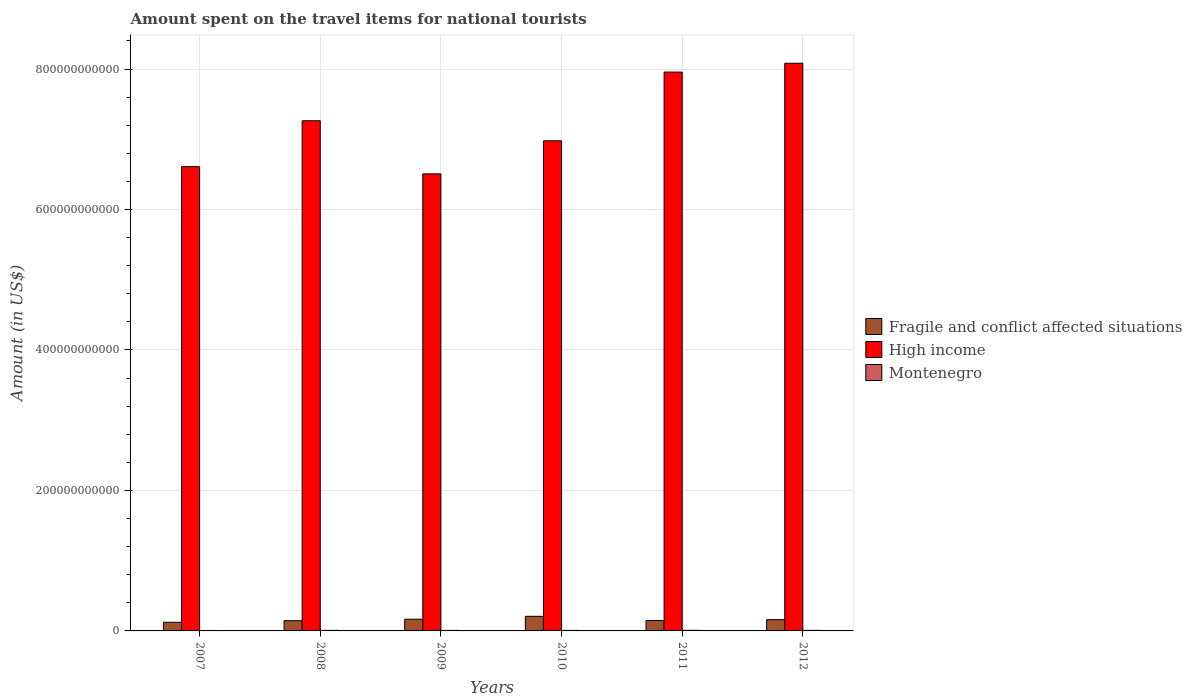How many different coloured bars are there?
Give a very brief answer. 3. Are the number of bars per tick equal to the number of legend labels?
Your response must be concise. Yes. How many bars are there on the 5th tick from the left?
Your answer should be very brief. 3. What is the label of the 6th group of bars from the left?
Provide a succinct answer. 2012. In how many cases, is the number of bars for a given year not equal to the number of legend labels?
Make the answer very short. 0. What is the amount spent on the travel items for national tourists in High income in 2009?
Your answer should be compact. 6.51e+11. Across all years, what is the maximum amount spent on the travel items for national tourists in Fragile and conflict affected situations?
Keep it short and to the point. 2.08e+1. Across all years, what is the minimum amount spent on the travel items for national tourists in High income?
Offer a terse response. 6.51e+11. What is the total amount spent on the travel items for national tourists in High income in the graph?
Make the answer very short. 4.34e+12. What is the difference between the amount spent on the travel items for national tourists in High income in 2009 and that in 2011?
Make the answer very short. -1.45e+11. What is the difference between the amount spent on the travel items for national tourists in High income in 2009 and the amount spent on the travel items for national tourists in Fragile and conflict affected situations in 2012?
Provide a succinct answer. 6.35e+11. What is the average amount spent on the travel items for national tourists in High income per year?
Give a very brief answer. 7.23e+11. In the year 2011, what is the difference between the amount spent on the travel items for national tourists in Montenegro and amount spent on the travel items for national tourists in High income?
Offer a terse response. -7.95e+11. What is the ratio of the amount spent on the travel items for national tourists in Fragile and conflict affected situations in 2008 to that in 2011?
Make the answer very short. 0.98. What is the difference between the highest and the second highest amount spent on the travel items for national tourists in Montenegro?
Provide a short and direct response. 6.20e+07. What is the difference between the highest and the lowest amount spent on the travel items for national tourists in Fragile and conflict affected situations?
Provide a short and direct response. 8.52e+09. Is the sum of the amount spent on the travel items for national tourists in High income in 2008 and 2011 greater than the maximum amount spent on the travel items for national tourists in Montenegro across all years?
Provide a short and direct response. Yes. What does the 3rd bar from the right in 2012 represents?
Provide a succinct answer. Fragile and conflict affected situations. Is it the case that in every year, the sum of the amount spent on the travel items for national tourists in High income and amount spent on the travel items for national tourists in Montenegro is greater than the amount spent on the travel items for national tourists in Fragile and conflict affected situations?
Your answer should be compact. Yes. What is the difference between two consecutive major ticks on the Y-axis?
Your answer should be compact. 2.00e+11. Does the graph contain any zero values?
Give a very brief answer. No. How many legend labels are there?
Keep it short and to the point. 3. What is the title of the graph?
Keep it short and to the point. Amount spent on the travel items for national tourists. What is the label or title of the X-axis?
Make the answer very short. Years. What is the Amount (in US$) in Fragile and conflict affected situations in 2007?
Your response must be concise. 1.23e+1. What is the Amount (in US$) of High income in 2007?
Keep it short and to the point. 6.61e+11. What is the Amount (in US$) of Montenegro in 2007?
Your answer should be very brief. 6.30e+08. What is the Amount (in US$) in Fragile and conflict affected situations in 2008?
Ensure brevity in your answer.  1.46e+1. What is the Amount (in US$) of High income in 2008?
Make the answer very short. 7.26e+11. What is the Amount (in US$) in Montenegro in 2008?
Make the answer very short. 8.13e+08. What is the Amount (in US$) in Fragile and conflict affected situations in 2009?
Offer a very short reply. 1.67e+1. What is the Amount (in US$) of High income in 2009?
Your answer should be very brief. 6.51e+11. What is the Amount (in US$) in Montenegro in 2009?
Your answer should be very brief. 7.45e+08. What is the Amount (in US$) in Fragile and conflict affected situations in 2010?
Provide a short and direct response. 2.08e+1. What is the Amount (in US$) of High income in 2010?
Keep it short and to the point. 6.98e+11. What is the Amount (in US$) of Montenegro in 2010?
Make the answer very short. 7.13e+08. What is the Amount (in US$) of Fragile and conflict affected situations in 2011?
Keep it short and to the point. 1.48e+1. What is the Amount (in US$) of High income in 2011?
Provide a short and direct response. 7.96e+11. What is the Amount (in US$) in Montenegro in 2011?
Offer a terse response. 8.75e+08. What is the Amount (in US$) of Fragile and conflict affected situations in 2012?
Ensure brevity in your answer.  1.60e+1. What is the Amount (in US$) of High income in 2012?
Your answer should be very brief. 8.08e+11. What is the Amount (in US$) in Montenegro in 2012?
Offer a very short reply. 8.09e+08. Across all years, what is the maximum Amount (in US$) in Fragile and conflict affected situations?
Provide a short and direct response. 2.08e+1. Across all years, what is the maximum Amount (in US$) of High income?
Provide a short and direct response. 8.08e+11. Across all years, what is the maximum Amount (in US$) of Montenegro?
Offer a terse response. 8.75e+08. Across all years, what is the minimum Amount (in US$) in Fragile and conflict affected situations?
Offer a very short reply. 1.23e+1. Across all years, what is the minimum Amount (in US$) in High income?
Provide a succinct answer. 6.51e+11. Across all years, what is the minimum Amount (in US$) of Montenegro?
Give a very brief answer. 6.30e+08. What is the total Amount (in US$) in Fragile and conflict affected situations in the graph?
Offer a terse response. 9.52e+1. What is the total Amount (in US$) in High income in the graph?
Keep it short and to the point. 4.34e+12. What is the total Amount (in US$) in Montenegro in the graph?
Your response must be concise. 4.58e+09. What is the difference between the Amount (in US$) of Fragile and conflict affected situations in 2007 and that in 2008?
Ensure brevity in your answer.  -2.30e+09. What is the difference between the Amount (in US$) in High income in 2007 and that in 2008?
Give a very brief answer. -6.53e+1. What is the difference between the Amount (in US$) of Montenegro in 2007 and that in 2008?
Your answer should be compact. -1.83e+08. What is the difference between the Amount (in US$) of Fragile and conflict affected situations in 2007 and that in 2009?
Make the answer very short. -4.39e+09. What is the difference between the Amount (in US$) of High income in 2007 and that in 2009?
Keep it short and to the point. 1.03e+1. What is the difference between the Amount (in US$) in Montenegro in 2007 and that in 2009?
Ensure brevity in your answer.  -1.15e+08. What is the difference between the Amount (in US$) in Fragile and conflict affected situations in 2007 and that in 2010?
Your answer should be very brief. -8.52e+09. What is the difference between the Amount (in US$) in High income in 2007 and that in 2010?
Your answer should be compact. -3.68e+1. What is the difference between the Amount (in US$) in Montenegro in 2007 and that in 2010?
Keep it short and to the point. -8.30e+07. What is the difference between the Amount (in US$) of Fragile and conflict affected situations in 2007 and that in 2011?
Ensure brevity in your answer.  -2.55e+09. What is the difference between the Amount (in US$) in High income in 2007 and that in 2011?
Offer a very short reply. -1.35e+11. What is the difference between the Amount (in US$) in Montenegro in 2007 and that in 2011?
Offer a very short reply. -2.45e+08. What is the difference between the Amount (in US$) of Fragile and conflict affected situations in 2007 and that in 2012?
Offer a very short reply. -3.75e+09. What is the difference between the Amount (in US$) of High income in 2007 and that in 2012?
Provide a succinct answer. -1.47e+11. What is the difference between the Amount (in US$) in Montenegro in 2007 and that in 2012?
Your response must be concise. -1.79e+08. What is the difference between the Amount (in US$) in Fragile and conflict affected situations in 2008 and that in 2009?
Provide a short and direct response. -2.10e+09. What is the difference between the Amount (in US$) in High income in 2008 and that in 2009?
Make the answer very short. 7.56e+1. What is the difference between the Amount (in US$) of Montenegro in 2008 and that in 2009?
Keep it short and to the point. 6.80e+07. What is the difference between the Amount (in US$) in Fragile and conflict affected situations in 2008 and that in 2010?
Give a very brief answer. -6.22e+09. What is the difference between the Amount (in US$) of High income in 2008 and that in 2010?
Your answer should be compact. 2.85e+1. What is the difference between the Amount (in US$) in Fragile and conflict affected situations in 2008 and that in 2011?
Make the answer very short. -2.51e+08. What is the difference between the Amount (in US$) in High income in 2008 and that in 2011?
Make the answer very short. -6.93e+1. What is the difference between the Amount (in US$) of Montenegro in 2008 and that in 2011?
Your answer should be very brief. -6.20e+07. What is the difference between the Amount (in US$) in Fragile and conflict affected situations in 2008 and that in 2012?
Give a very brief answer. -1.45e+09. What is the difference between the Amount (in US$) of High income in 2008 and that in 2012?
Keep it short and to the point. -8.19e+1. What is the difference between the Amount (in US$) of Fragile and conflict affected situations in 2009 and that in 2010?
Your answer should be very brief. -4.12e+09. What is the difference between the Amount (in US$) in High income in 2009 and that in 2010?
Offer a terse response. -4.71e+1. What is the difference between the Amount (in US$) of Montenegro in 2009 and that in 2010?
Provide a short and direct response. 3.20e+07. What is the difference between the Amount (in US$) of Fragile and conflict affected situations in 2009 and that in 2011?
Give a very brief answer. 1.85e+09. What is the difference between the Amount (in US$) of High income in 2009 and that in 2011?
Provide a succinct answer. -1.45e+11. What is the difference between the Amount (in US$) of Montenegro in 2009 and that in 2011?
Give a very brief answer. -1.30e+08. What is the difference between the Amount (in US$) of Fragile and conflict affected situations in 2009 and that in 2012?
Keep it short and to the point. 6.47e+08. What is the difference between the Amount (in US$) in High income in 2009 and that in 2012?
Your response must be concise. -1.58e+11. What is the difference between the Amount (in US$) of Montenegro in 2009 and that in 2012?
Your response must be concise. -6.40e+07. What is the difference between the Amount (in US$) of Fragile and conflict affected situations in 2010 and that in 2011?
Provide a succinct answer. 5.97e+09. What is the difference between the Amount (in US$) of High income in 2010 and that in 2011?
Provide a succinct answer. -9.78e+1. What is the difference between the Amount (in US$) in Montenegro in 2010 and that in 2011?
Make the answer very short. -1.62e+08. What is the difference between the Amount (in US$) in Fragile and conflict affected situations in 2010 and that in 2012?
Your answer should be very brief. 4.77e+09. What is the difference between the Amount (in US$) of High income in 2010 and that in 2012?
Your response must be concise. -1.10e+11. What is the difference between the Amount (in US$) of Montenegro in 2010 and that in 2012?
Provide a short and direct response. -9.60e+07. What is the difference between the Amount (in US$) of Fragile and conflict affected situations in 2011 and that in 2012?
Give a very brief answer. -1.20e+09. What is the difference between the Amount (in US$) in High income in 2011 and that in 2012?
Your answer should be very brief. -1.25e+1. What is the difference between the Amount (in US$) of Montenegro in 2011 and that in 2012?
Make the answer very short. 6.60e+07. What is the difference between the Amount (in US$) of Fragile and conflict affected situations in 2007 and the Amount (in US$) of High income in 2008?
Ensure brevity in your answer.  -7.14e+11. What is the difference between the Amount (in US$) in Fragile and conflict affected situations in 2007 and the Amount (in US$) in Montenegro in 2008?
Offer a very short reply. 1.15e+1. What is the difference between the Amount (in US$) of High income in 2007 and the Amount (in US$) of Montenegro in 2008?
Your response must be concise. 6.60e+11. What is the difference between the Amount (in US$) in Fragile and conflict affected situations in 2007 and the Amount (in US$) in High income in 2009?
Your response must be concise. -6.38e+11. What is the difference between the Amount (in US$) in Fragile and conflict affected situations in 2007 and the Amount (in US$) in Montenegro in 2009?
Your answer should be compact. 1.15e+1. What is the difference between the Amount (in US$) of High income in 2007 and the Amount (in US$) of Montenegro in 2009?
Give a very brief answer. 6.60e+11. What is the difference between the Amount (in US$) of Fragile and conflict affected situations in 2007 and the Amount (in US$) of High income in 2010?
Offer a very short reply. -6.86e+11. What is the difference between the Amount (in US$) in Fragile and conflict affected situations in 2007 and the Amount (in US$) in Montenegro in 2010?
Your answer should be compact. 1.16e+1. What is the difference between the Amount (in US$) of High income in 2007 and the Amount (in US$) of Montenegro in 2010?
Offer a terse response. 6.60e+11. What is the difference between the Amount (in US$) of Fragile and conflict affected situations in 2007 and the Amount (in US$) of High income in 2011?
Provide a succinct answer. -7.83e+11. What is the difference between the Amount (in US$) in Fragile and conflict affected situations in 2007 and the Amount (in US$) in Montenegro in 2011?
Your response must be concise. 1.14e+1. What is the difference between the Amount (in US$) of High income in 2007 and the Amount (in US$) of Montenegro in 2011?
Offer a very short reply. 6.60e+11. What is the difference between the Amount (in US$) of Fragile and conflict affected situations in 2007 and the Amount (in US$) of High income in 2012?
Provide a succinct answer. -7.96e+11. What is the difference between the Amount (in US$) of Fragile and conflict affected situations in 2007 and the Amount (in US$) of Montenegro in 2012?
Make the answer very short. 1.15e+1. What is the difference between the Amount (in US$) of High income in 2007 and the Amount (in US$) of Montenegro in 2012?
Your answer should be compact. 6.60e+11. What is the difference between the Amount (in US$) in Fragile and conflict affected situations in 2008 and the Amount (in US$) in High income in 2009?
Your answer should be very brief. -6.36e+11. What is the difference between the Amount (in US$) in Fragile and conflict affected situations in 2008 and the Amount (in US$) in Montenegro in 2009?
Keep it short and to the point. 1.38e+1. What is the difference between the Amount (in US$) in High income in 2008 and the Amount (in US$) in Montenegro in 2009?
Your answer should be compact. 7.26e+11. What is the difference between the Amount (in US$) in Fragile and conflict affected situations in 2008 and the Amount (in US$) in High income in 2010?
Ensure brevity in your answer.  -6.83e+11. What is the difference between the Amount (in US$) in Fragile and conflict affected situations in 2008 and the Amount (in US$) in Montenegro in 2010?
Offer a terse response. 1.39e+1. What is the difference between the Amount (in US$) of High income in 2008 and the Amount (in US$) of Montenegro in 2010?
Provide a succinct answer. 7.26e+11. What is the difference between the Amount (in US$) in Fragile and conflict affected situations in 2008 and the Amount (in US$) in High income in 2011?
Make the answer very short. -7.81e+11. What is the difference between the Amount (in US$) in Fragile and conflict affected situations in 2008 and the Amount (in US$) in Montenegro in 2011?
Provide a short and direct response. 1.37e+1. What is the difference between the Amount (in US$) in High income in 2008 and the Amount (in US$) in Montenegro in 2011?
Your answer should be very brief. 7.26e+11. What is the difference between the Amount (in US$) of Fragile and conflict affected situations in 2008 and the Amount (in US$) of High income in 2012?
Ensure brevity in your answer.  -7.94e+11. What is the difference between the Amount (in US$) in Fragile and conflict affected situations in 2008 and the Amount (in US$) in Montenegro in 2012?
Your answer should be compact. 1.38e+1. What is the difference between the Amount (in US$) in High income in 2008 and the Amount (in US$) in Montenegro in 2012?
Offer a very short reply. 7.26e+11. What is the difference between the Amount (in US$) in Fragile and conflict affected situations in 2009 and the Amount (in US$) in High income in 2010?
Keep it short and to the point. -6.81e+11. What is the difference between the Amount (in US$) of Fragile and conflict affected situations in 2009 and the Amount (in US$) of Montenegro in 2010?
Your answer should be compact. 1.60e+1. What is the difference between the Amount (in US$) of High income in 2009 and the Amount (in US$) of Montenegro in 2010?
Give a very brief answer. 6.50e+11. What is the difference between the Amount (in US$) of Fragile and conflict affected situations in 2009 and the Amount (in US$) of High income in 2011?
Offer a terse response. -7.79e+11. What is the difference between the Amount (in US$) of Fragile and conflict affected situations in 2009 and the Amount (in US$) of Montenegro in 2011?
Offer a very short reply. 1.58e+1. What is the difference between the Amount (in US$) of High income in 2009 and the Amount (in US$) of Montenegro in 2011?
Keep it short and to the point. 6.50e+11. What is the difference between the Amount (in US$) in Fragile and conflict affected situations in 2009 and the Amount (in US$) in High income in 2012?
Give a very brief answer. -7.92e+11. What is the difference between the Amount (in US$) of Fragile and conflict affected situations in 2009 and the Amount (in US$) of Montenegro in 2012?
Your answer should be compact. 1.59e+1. What is the difference between the Amount (in US$) in High income in 2009 and the Amount (in US$) in Montenegro in 2012?
Offer a terse response. 6.50e+11. What is the difference between the Amount (in US$) in Fragile and conflict affected situations in 2010 and the Amount (in US$) in High income in 2011?
Ensure brevity in your answer.  -7.75e+11. What is the difference between the Amount (in US$) in Fragile and conflict affected situations in 2010 and the Amount (in US$) in Montenegro in 2011?
Give a very brief answer. 1.99e+1. What is the difference between the Amount (in US$) in High income in 2010 and the Amount (in US$) in Montenegro in 2011?
Offer a terse response. 6.97e+11. What is the difference between the Amount (in US$) in Fragile and conflict affected situations in 2010 and the Amount (in US$) in High income in 2012?
Give a very brief answer. -7.87e+11. What is the difference between the Amount (in US$) in Fragile and conflict affected situations in 2010 and the Amount (in US$) in Montenegro in 2012?
Ensure brevity in your answer.  2.00e+1. What is the difference between the Amount (in US$) of High income in 2010 and the Amount (in US$) of Montenegro in 2012?
Ensure brevity in your answer.  6.97e+11. What is the difference between the Amount (in US$) of Fragile and conflict affected situations in 2011 and the Amount (in US$) of High income in 2012?
Offer a very short reply. -7.93e+11. What is the difference between the Amount (in US$) in Fragile and conflict affected situations in 2011 and the Amount (in US$) in Montenegro in 2012?
Keep it short and to the point. 1.40e+1. What is the difference between the Amount (in US$) of High income in 2011 and the Amount (in US$) of Montenegro in 2012?
Give a very brief answer. 7.95e+11. What is the average Amount (in US$) of Fragile and conflict affected situations per year?
Your answer should be compact. 1.59e+1. What is the average Amount (in US$) of High income per year?
Make the answer very short. 7.23e+11. What is the average Amount (in US$) of Montenegro per year?
Provide a succinct answer. 7.64e+08. In the year 2007, what is the difference between the Amount (in US$) in Fragile and conflict affected situations and Amount (in US$) in High income?
Ensure brevity in your answer.  -6.49e+11. In the year 2007, what is the difference between the Amount (in US$) of Fragile and conflict affected situations and Amount (in US$) of Montenegro?
Ensure brevity in your answer.  1.16e+1. In the year 2007, what is the difference between the Amount (in US$) in High income and Amount (in US$) in Montenegro?
Offer a terse response. 6.60e+11. In the year 2008, what is the difference between the Amount (in US$) in Fragile and conflict affected situations and Amount (in US$) in High income?
Give a very brief answer. -7.12e+11. In the year 2008, what is the difference between the Amount (in US$) in Fragile and conflict affected situations and Amount (in US$) in Montenegro?
Offer a terse response. 1.38e+1. In the year 2008, what is the difference between the Amount (in US$) in High income and Amount (in US$) in Montenegro?
Ensure brevity in your answer.  7.26e+11. In the year 2009, what is the difference between the Amount (in US$) of Fragile and conflict affected situations and Amount (in US$) of High income?
Your answer should be very brief. -6.34e+11. In the year 2009, what is the difference between the Amount (in US$) of Fragile and conflict affected situations and Amount (in US$) of Montenegro?
Make the answer very short. 1.59e+1. In the year 2009, what is the difference between the Amount (in US$) of High income and Amount (in US$) of Montenegro?
Make the answer very short. 6.50e+11. In the year 2010, what is the difference between the Amount (in US$) of Fragile and conflict affected situations and Amount (in US$) of High income?
Ensure brevity in your answer.  -6.77e+11. In the year 2010, what is the difference between the Amount (in US$) in Fragile and conflict affected situations and Amount (in US$) in Montenegro?
Ensure brevity in your answer.  2.01e+1. In the year 2010, what is the difference between the Amount (in US$) of High income and Amount (in US$) of Montenegro?
Keep it short and to the point. 6.97e+11. In the year 2011, what is the difference between the Amount (in US$) in Fragile and conflict affected situations and Amount (in US$) in High income?
Give a very brief answer. -7.81e+11. In the year 2011, what is the difference between the Amount (in US$) of Fragile and conflict affected situations and Amount (in US$) of Montenegro?
Ensure brevity in your answer.  1.40e+1. In the year 2011, what is the difference between the Amount (in US$) of High income and Amount (in US$) of Montenegro?
Provide a short and direct response. 7.95e+11. In the year 2012, what is the difference between the Amount (in US$) of Fragile and conflict affected situations and Amount (in US$) of High income?
Your answer should be very brief. -7.92e+11. In the year 2012, what is the difference between the Amount (in US$) in Fragile and conflict affected situations and Amount (in US$) in Montenegro?
Provide a succinct answer. 1.52e+1. In the year 2012, what is the difference between the Amount (in US$) in High income and Amount (in US$) in Montenegro?
Keep it short and to the point. 8.07e+11. What is the ratio of the Amount (in US$) in Fragile and conflict affected situations in 2007 to that in 2008?
Ensure brevity in your answer.  0.84. What is the ratio of the Amount (in US$) in High income in 2007 to that in 2008?
Keep it short and to the point. 0.91. What is the ratio of the Amount (in US$) in Montenegro in 2007 to that in 2008?
Make the answer very short. 0.77. What is the ratio of the Amount (in US$) in Fragile and conflict affected situations in 2007 to that in 2009?
Your answer should be very brief. 0.74. What is the ratio of the Amount (in US$) in High income in 2007 to that in 2009?
Keep it short and to the point. 1.02. What is the ratio of the Amount (in US$) of Montenegro in 2007 to that in 2009?
Keep it short and to the point. 0.85. What is the ratio of the Amount (in US$) of Fragile and conflict affected situations in 2007 to that in 2010?
Offer a very short reply. 0.59. What is the ratio of the Amount (in US$) in High income in 2007 to that in 2010?
Give a very brief answer. 0.95. What is the ratio of the Amount (in US$) of Montenegro in 2007 to that in 2010?
Offer a very short reply. 0.88. What is the ratio of the Amount (in US$) in Fragile and conflict affected situations in 2007 to that in 2011?
Ensure brevity in your answer.  0.83. What is the ratio of the Amount (in US$) of High income in 2007 to that in 2011?
Ensure brevity in your answer.  0.83. What is the ratio of the Amount (in US$) of Montenegro in 2007 to that in 2011?
Offer a terse response. 0.72. What is the ratio of the Amount (in US$) in Fragile and conflict affected situations in 2007 to that in 2012?
Give a very brief answer. 0.77. What is the ratio of the Amount (in US$) in High income in 2007 to that in 2012?
Your answer should be compact. 0.82. What is the ratio of the Amount (in US$) of Montenegro in 2007 to that in 2012?
Provide a succinct answer. 0.78. What is the ratio of the Amount (in US$) of Fragile and conflict affected situations in 2008 to that in 2009?
Your answer should be very brief. 0.87. What is the ratio of the Amount (in US$) in High income in 2008 to that in 2009?
Give a very brief answer. 1.12. What is the ratio of the Amount (in US$) of Montenegro in 2008 to that in 2009?
Keep it short and to the point. 1.09. What is the ratio of the Amount (in US$) of Fragile and conflict affected situations in 2008 to that in 2010?
Make the answer very short. 0.7. What is the ratio of the Amount (in US$) in High income in 2008 to that in 2010?
Make the answer very short. 1.04. What is the ratio of the Amount (in US$) of Montenegro in 2008 to that in 2010?
Provide a short and direct response. 1.14. What is the ratio of the Amount (in US$) of Fragile and conflict affected situations in 2008 to that in 2011?
Offer a very short reply. 0.98. What is the ratio of the Amount (in US$) of High income in 2008 to that in 2011?
Provide a short and direct response. 0.91. What is the ratio of the Amount (in US$) in Montenegro in 2008 to that in 2011?
Keep it short and to the point. 0.93. What is the ratio of the Amount (in US$) in Fragile and conflict affected situations in 2008 to that in 2012?
Ensure brevity in your answer.  0.91. What is the ratio of the Amount (in US$) in High income in 2008 to that in 2012?
Offer a very short reply. 0.9. What is the ratio of the Amount (in US$) in Fragile and conflict affected situations in 2009 to that in 2010?
Offer a terse response. 0.8. What is the ratio of the Amount (in US$) in High income in 2009 to that in 2010?
Give a very brief answer. 0.93. What is the ratio of the Amount (in US$) in Montenegro in 2009 to that in 2010?
Provide a short and direct response. 1.04. What is the ratio of the Amount (in US$) in Fragile and conflict affected situations in 2009 to that in 2011?
Offer a terse response. 1.12. What is the ratio of the Amount (in US$) of High income in 2009 to that in 2011?
Make the answer very short. 0.82. What is the ratio of the Amount (in US$) of Montenegro in 2009 to that in 2011?
Your answer should be very brief. 0.85. What is the ratio of the Amount (in US$) in Fragile and conflict affected situations in 2009 to that in 2012?
Your answer should be compact. 1.04. What is the ratio of the Amount (in US$) of High income in 2009 to that in 2012?
Your answer should be very brief. 0.81. What is the ratio of the Amount (in US$) of Montenegro in 2009 to that in 2012?
Give a very brief answer. 0.92. What is the ratio of the Amount (in US$) in Fragile and conflict affected situations in 2010 to that in 2011?
Offer a terse response. 1.4. What is the ratio of the Amount (in US$) of High income in 2010 to that in 2011?
Give a very brief answer. 0.88. What is the ratio of the Amount (in US$) in Montenegro in 2010 to that in 2011?
Offer a terse response. 0.81. What is the ratio of the Amount (in US$) in Fragile and conflict affected situations in 2010 to that in 2012?
Keep it short and to the point. 1.3. What is the ratio of the Amount (in US$) in High income in 2010 to that in 2012?
Provide a short and direct response. 0.86. What is the ratio of the Amount (in US$) of Montenegro in 2010 to that in 2012?
Give a very brief answer. 0.88. What is the ratio of the Amount (in US$) of Fragile and conflict affected situations in 2011 to that in 2012?
Give a very brief answer. 0.93. What is the ratio of the Amount (in US$) of High income in 2011 to that in 2012?
Offer a terse response. 0.98. What is the ratio of the Amount (in US$) in Montenegro in 2011 to that in 2012?
Give a very brief answer. 1.08. What is the difference between the highest and the second highest Amount (in US$) of Fragile and conflict affected situations?
Your answer should be very brief. 4.12e+09. What is the difference between the highest and the second highest Amount (in US$) of High income?
Your response must be concise. 1.25e+1. What is the difference between the highest and the second highest Amount (in US$) in Montenegro?
Provide a short and direct response. 6.20e+07. What is the difference between the highest and the lowest Amount (in US$) of Fragile and conflict affected situations?
Offer a very short reply. 8.52e+09. What is the difference between the highest and the lowest Amount (in US$) in High income?
Give a very brief answer. 1.58e+11. What is the difference between the highest and the lowest Amount (in US$) of Montenegro?
Offer a terse response. 2.45e+08. 